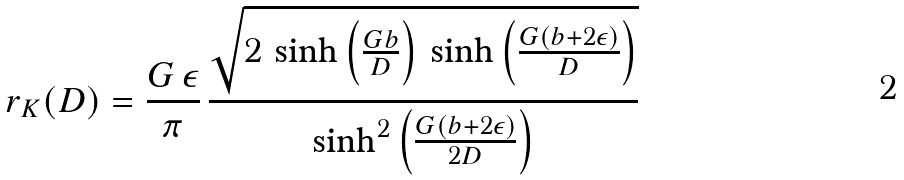<formula> <loc_0><loc_0><loc_500><loc_500>r _ { K } ( D ) = \frac { G \, \epsilon } { \pi } \, \frac { \sqrt { 2 \, \sinh \left ( \frac { G b } { D } \right ) \, \sinh \left ( \frac { G ( b + 2 \epsilon ) } { D } \right ) } } { { \sinh } ^ { 2 } \left ( \frac { G ( b + 2 \epsilon ) } { 2 D } \right ) }</formula> 